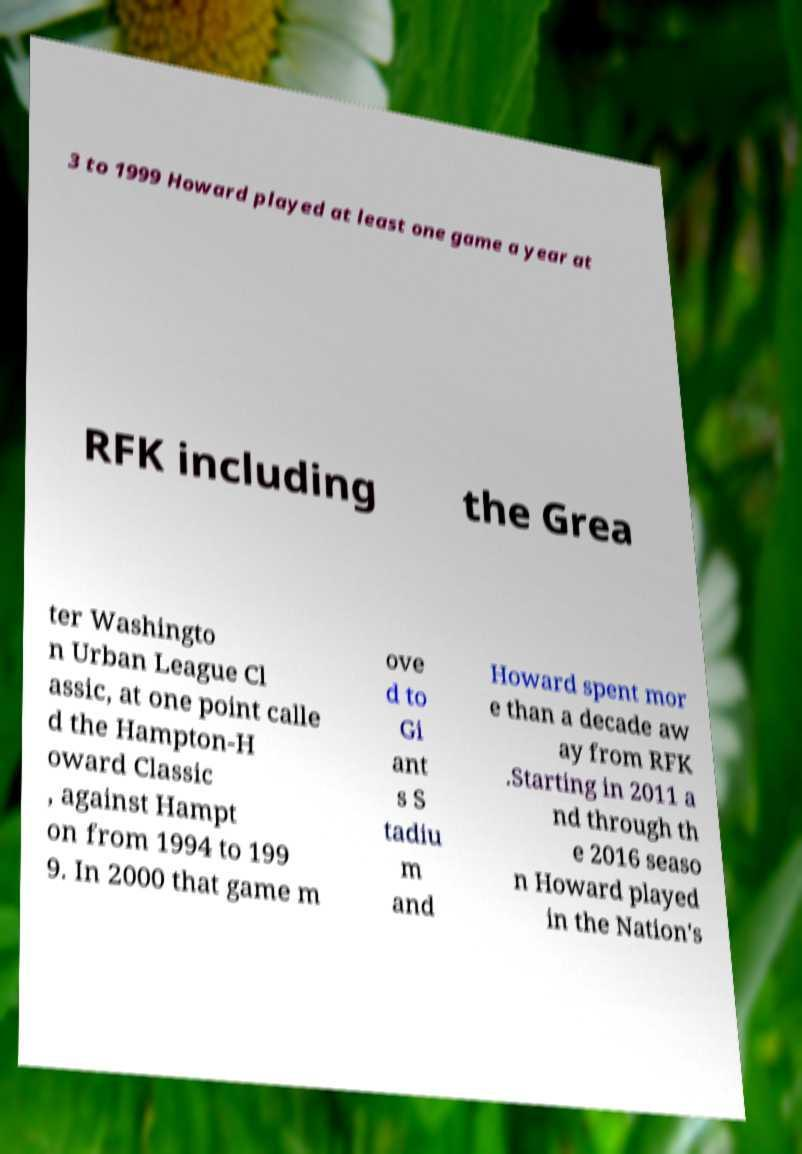Could you extract and type out the text from this image? 3 to 1999 Howard played at least one game a year at RFK including the Grea ter Washingto n Urban League Cl assic, at one point calle d the Hampton-H oward Classic , against Hampt on from 1994 to 199 9. In 2000 that game m ove d to Gi ant s S tadiu m and Howard spent mor e than a decade aw ay from RFK .Starting in 2011 a nd through th e 2016 seaso n Howard played in the Nation's 